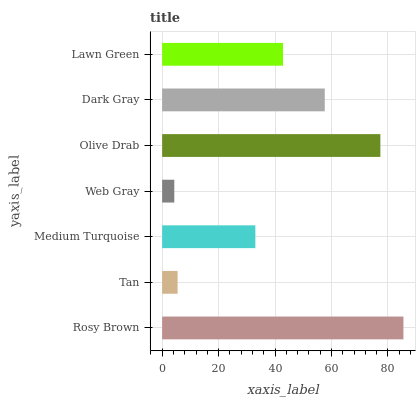Is Web Gray the minimum?
Answer yes or no. Yes. Is Rosy Brown the maximum?
Answer yes or no. Yes. Is Tan the minimum?
Answer yes or no. No. Is Tan the maximum?
Answer yes or no. No. Is Rosy Brown greater than Tan?
Answer yes or no. Yes. Is Tan less than Rosy Brown?
Answer yes or no. Yes. Is Tan greater than Rosy Brown?
Answer yes or no. No. Is Rosy Brown less than Tan?
Answer yes or no. No. Is Lawn Green the high median?
Answer yes or no. Yes. Is Lawn Green the low median?
Answer yes or no. Yes. Is Dark Gray the high median?
Answer yes or no. No. Is Medium Turquoise the low median?
Answer yes or no. No. 